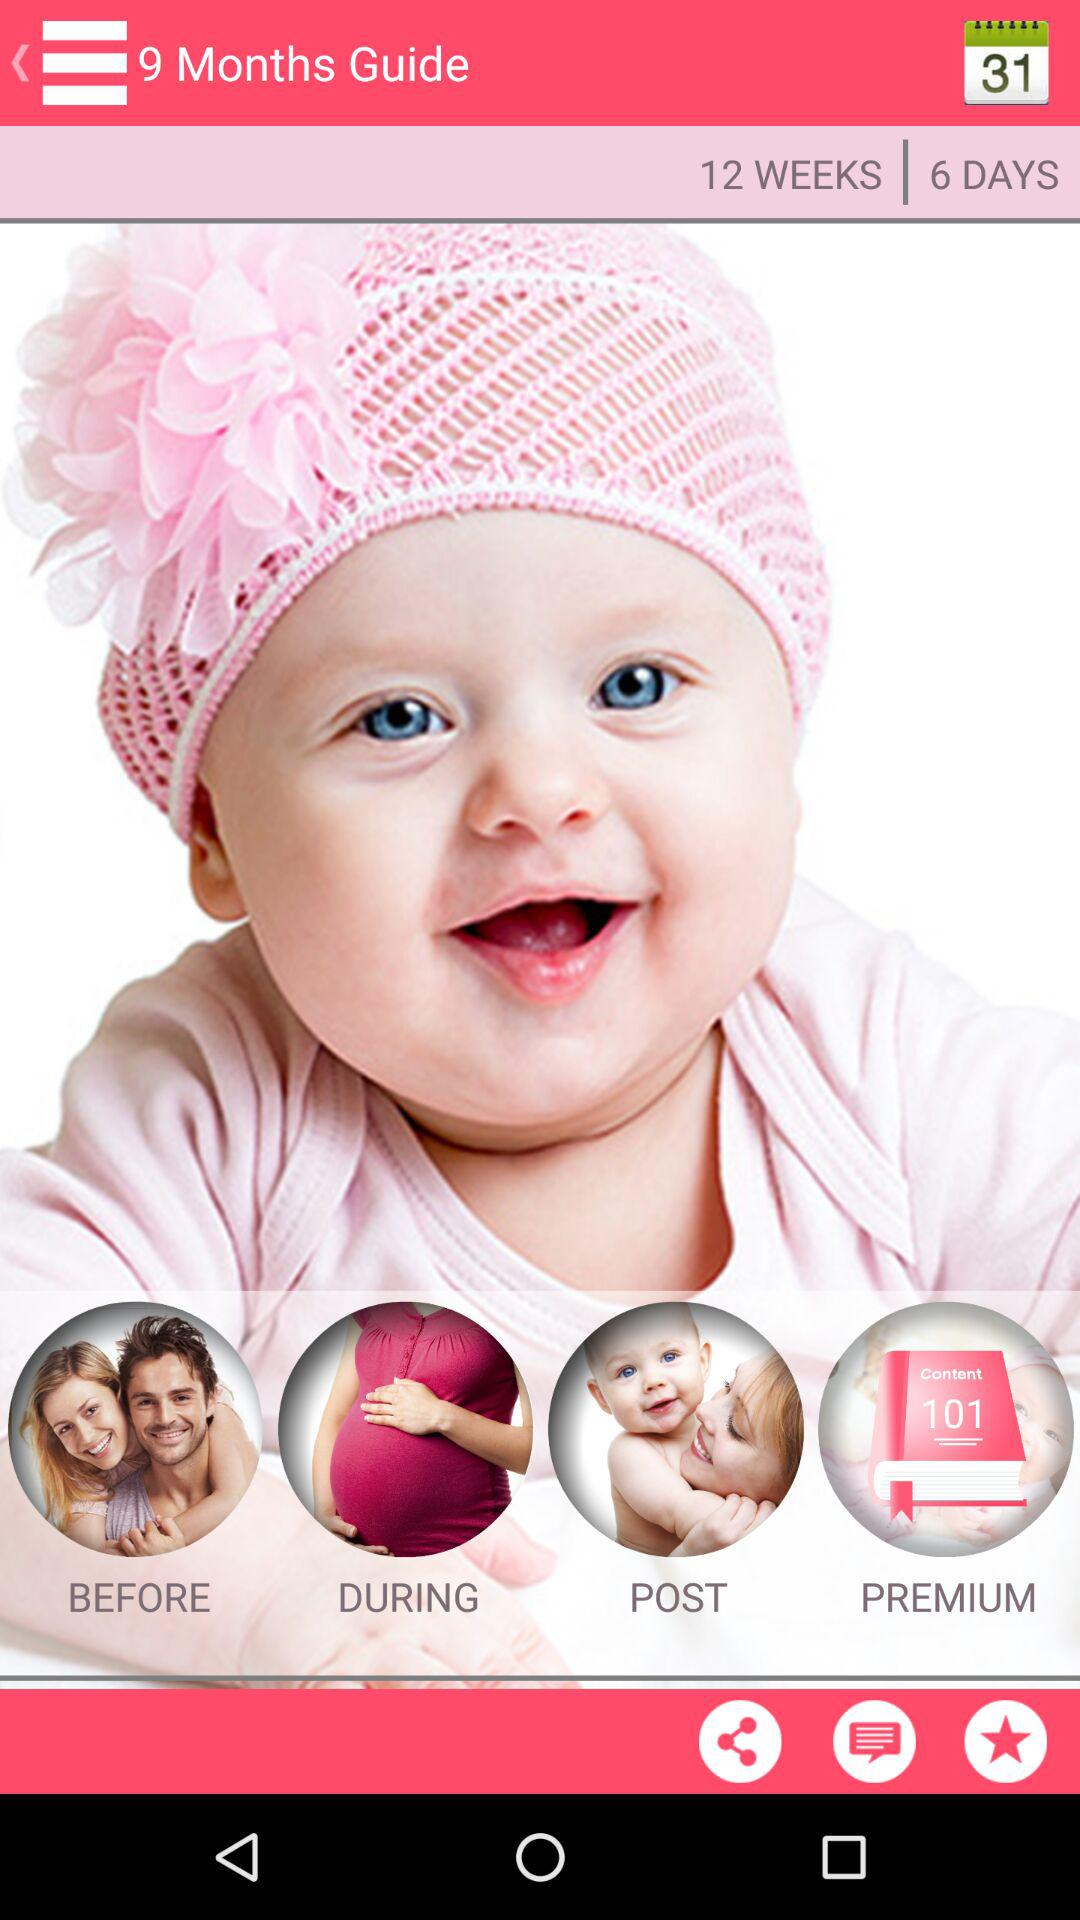How many weeks are there? There are 12 weeks. 